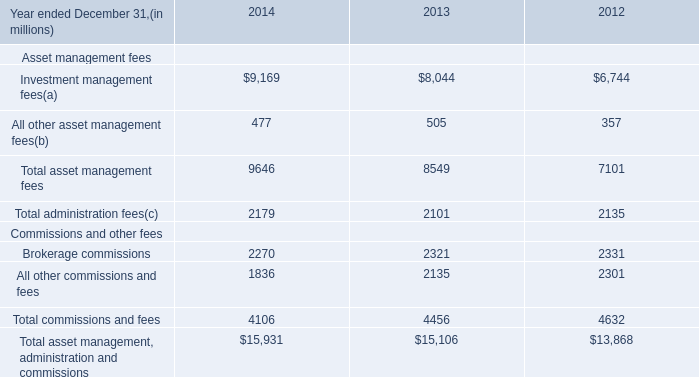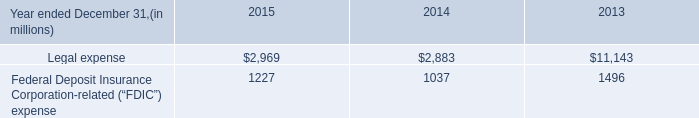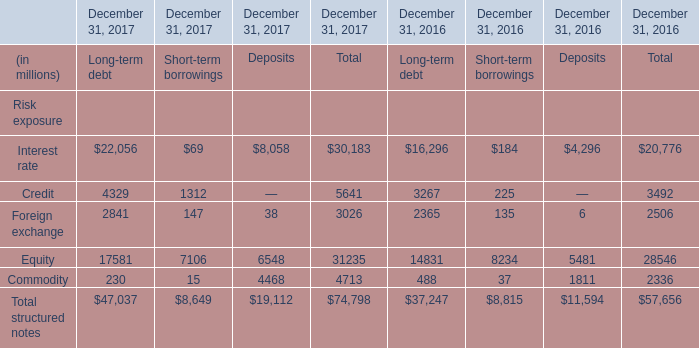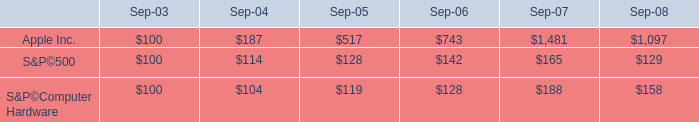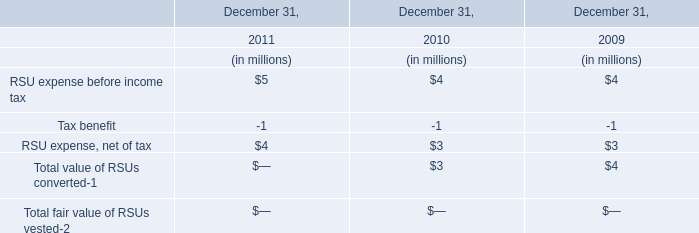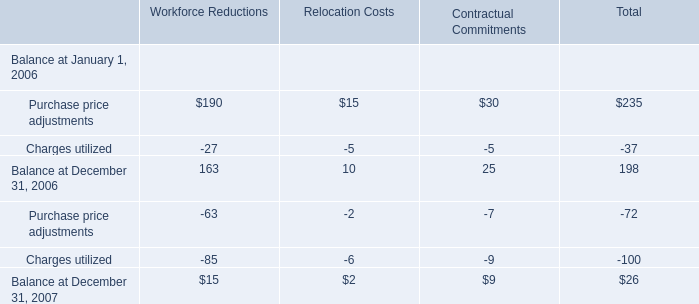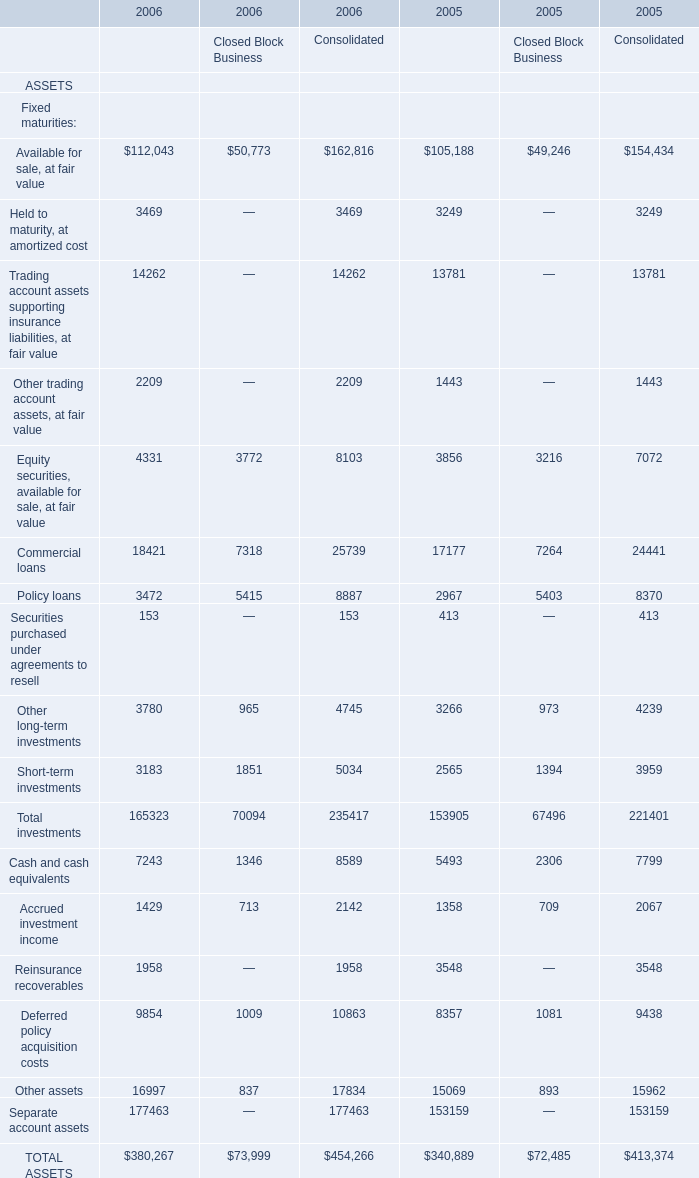What is the growing rate of Credit in the year with the most Interest rate for Total？ 
Computations: ((5641 - 3492) / 5641)
Answer: 0.38096. 